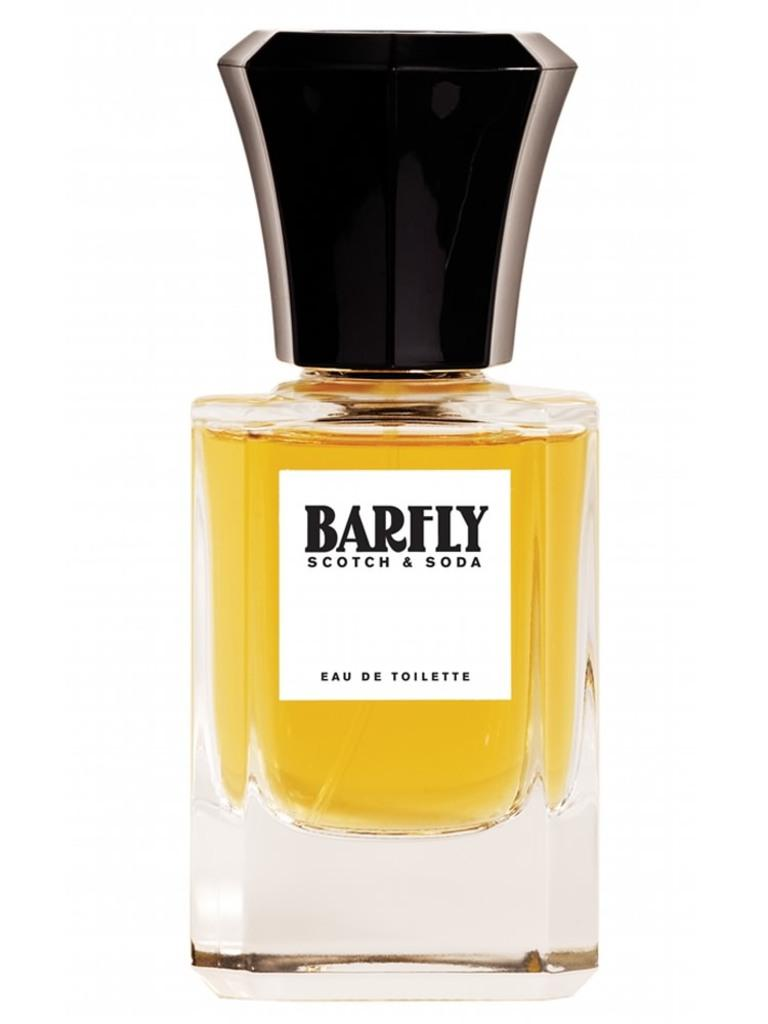<image>
Share a concise interpretation of the image provided. Perfume bottle of Barfly Scotch & Soda with a black cap. 